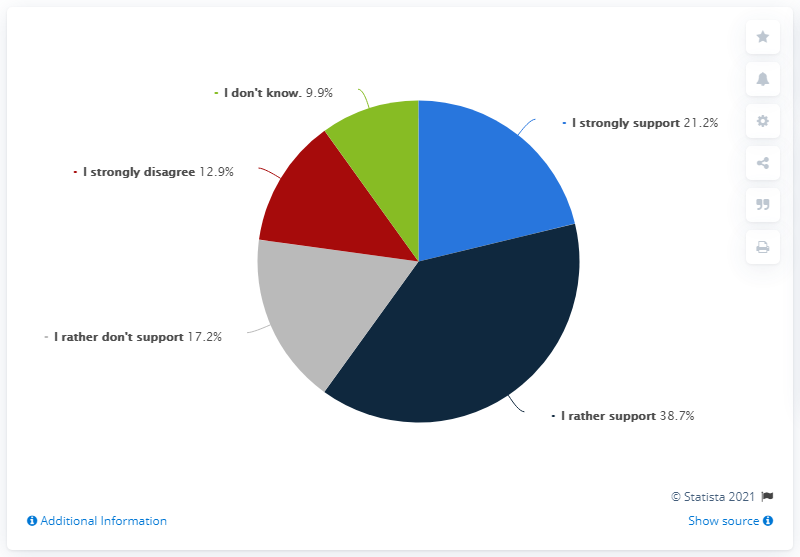Give some essential details in this illustration. It is estimated that 5 opinions have been taken. A strong majority of 59.9% of people support . 